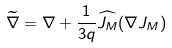<formula> <loc_0><loc_0><loc_500><loc_500>\widetilde { \nabla } = \nabla + \frac { 1 } { 3 q } \widehat { J _ { M } } ( { \nabla } J _ { M } )</formula> 